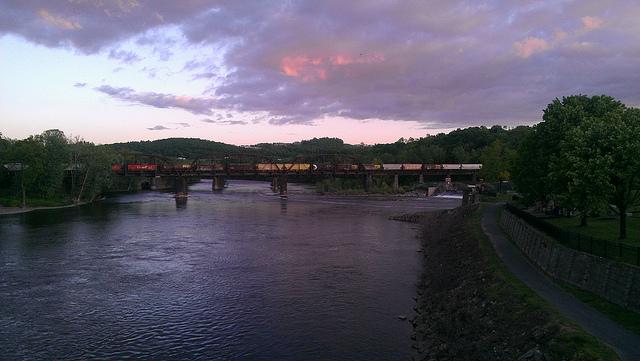What is on the water?
Be succinct. Nothing. How many boats are on the water?
Concise answer only. 0. Could the camera be pointing west?
Keep it brief. Yes. What lake is the name of the lake?
Quick response, please. Don't know. How many trees are in the photo?
Short answer required. 50. Is this time of day sunset?
Answer briefly. Yes. 